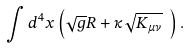<formula> <loc_0><loc_0><loc_500><loc_500>\int d ^ { 4 } x \left ( \sqrt { g } R + \kappa \sqrt { K _ { \mu \nu } } \ \right ) .</formula> 